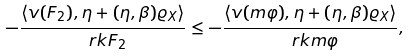Convert formula to latex. <formula><loc_0><loc_0><loc_500><loc_500>- \frac { \langle v ( F _ { 2 } ) , \eta + ( \eta , \beta ) \varrho _ { X } \rangle } { \ r k F _ { 2 } } \leq - \frac { \langle v ( \i m \varphi ) , \eta + ( \eta , \beta ) \varrho _ { X } \rangle } { \ r k \i m \varphi } ,</formula> 